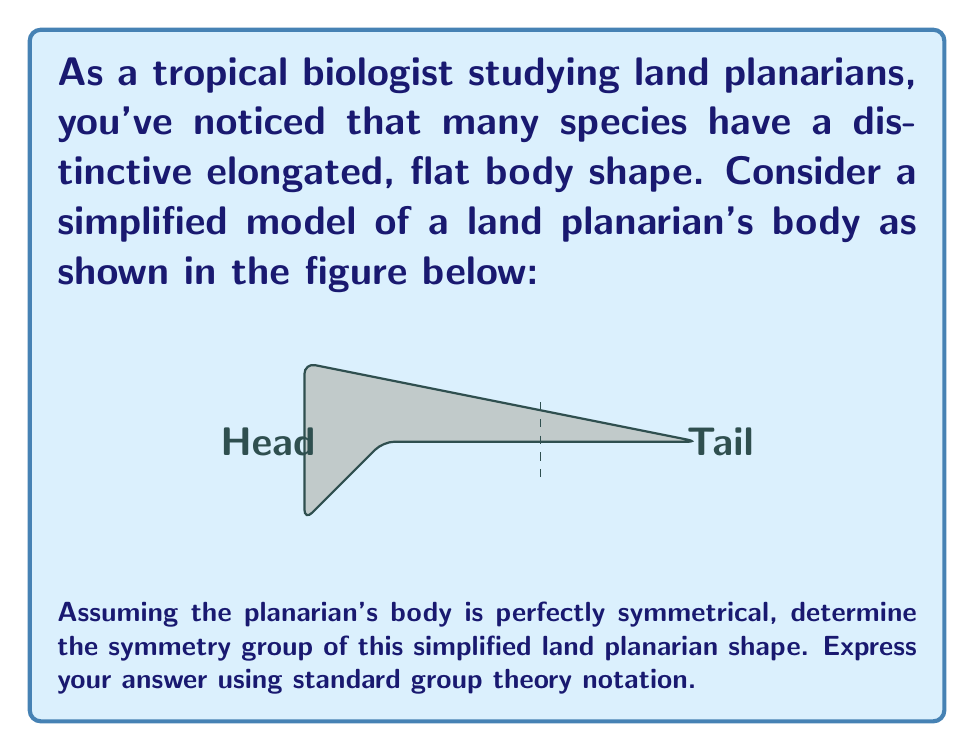Teach me how to tackle this problem. To determine the symmetry group of the land planarian's body shape, let's analyze its symmetries step by step:

1. Rotational symmetry:
   The shape has no rotational symmetry other than the identity rotation (360°), as rotating it by any other angle would not preserve the shape.

2. Reflection symmetry:
   There is one line of reflection symmetry, which is the vertical line passing through the center of the body (shown as a dashed line in the figure).

3. Identity transformation:
   The identity transformation (doing nothing) is always a symmetry.

These symmetries form a group under composition. Let's identify the elements:
- e: identity transformation
- r: reflection about the vertical line

We can verify that these form a group:
- Closure: e∘e = e, e∘r = r, r∘e = r, r∘r = e
- Associativity: holds for all transformations
- Identity: e is the identity element
- Inverse: e⁻¹ = e, r⁻¹ = r

This group has order 2 and is isomorphic to the cyclic group of order 2, denoted as $C_2$ or $\mathbb{Z}_2$.

In standard group theory notation, we can express this symmetry group as:

$$G = \{e, r\} \cong C_2 \cong \mathbb{Z}_2$$

This group is also isomorphic to the dihedral group $D_1$, which is the symmetry group of a line segment.
Answer: $C_2$ or $\mathbb{Z}_2$ 